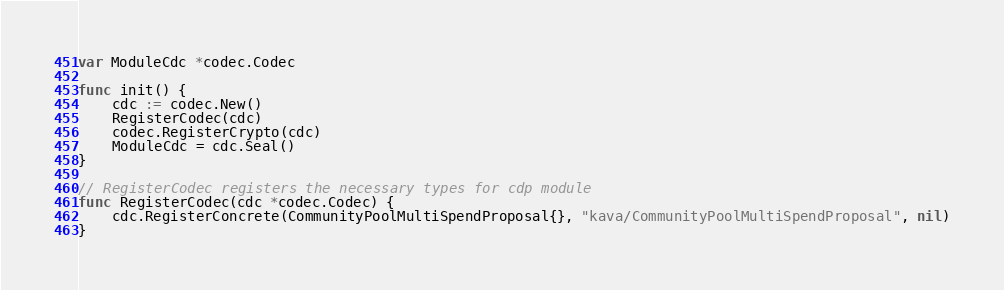Convert code to text. <code><loc_0><loc_0><loc_500><loc_500><_Go_>var ModuleCdc *codec.Codec

func init() {
	cdc := codec.New()
	RegisterCodec(cdc)
	codec.RegisterCrypto(cdc)
	ModuleCdc = cdc.Seal()
}

// RegisterCodec registers the necessary types for cdp module
func RegisterCodec(cdc *codec.Codec) {
	cdc.RegisterConcrete(CommunityPoolMultiSpendProposal{}, "kava/CommunityPoolMultiSpendProposal", nil)
}
</code> 